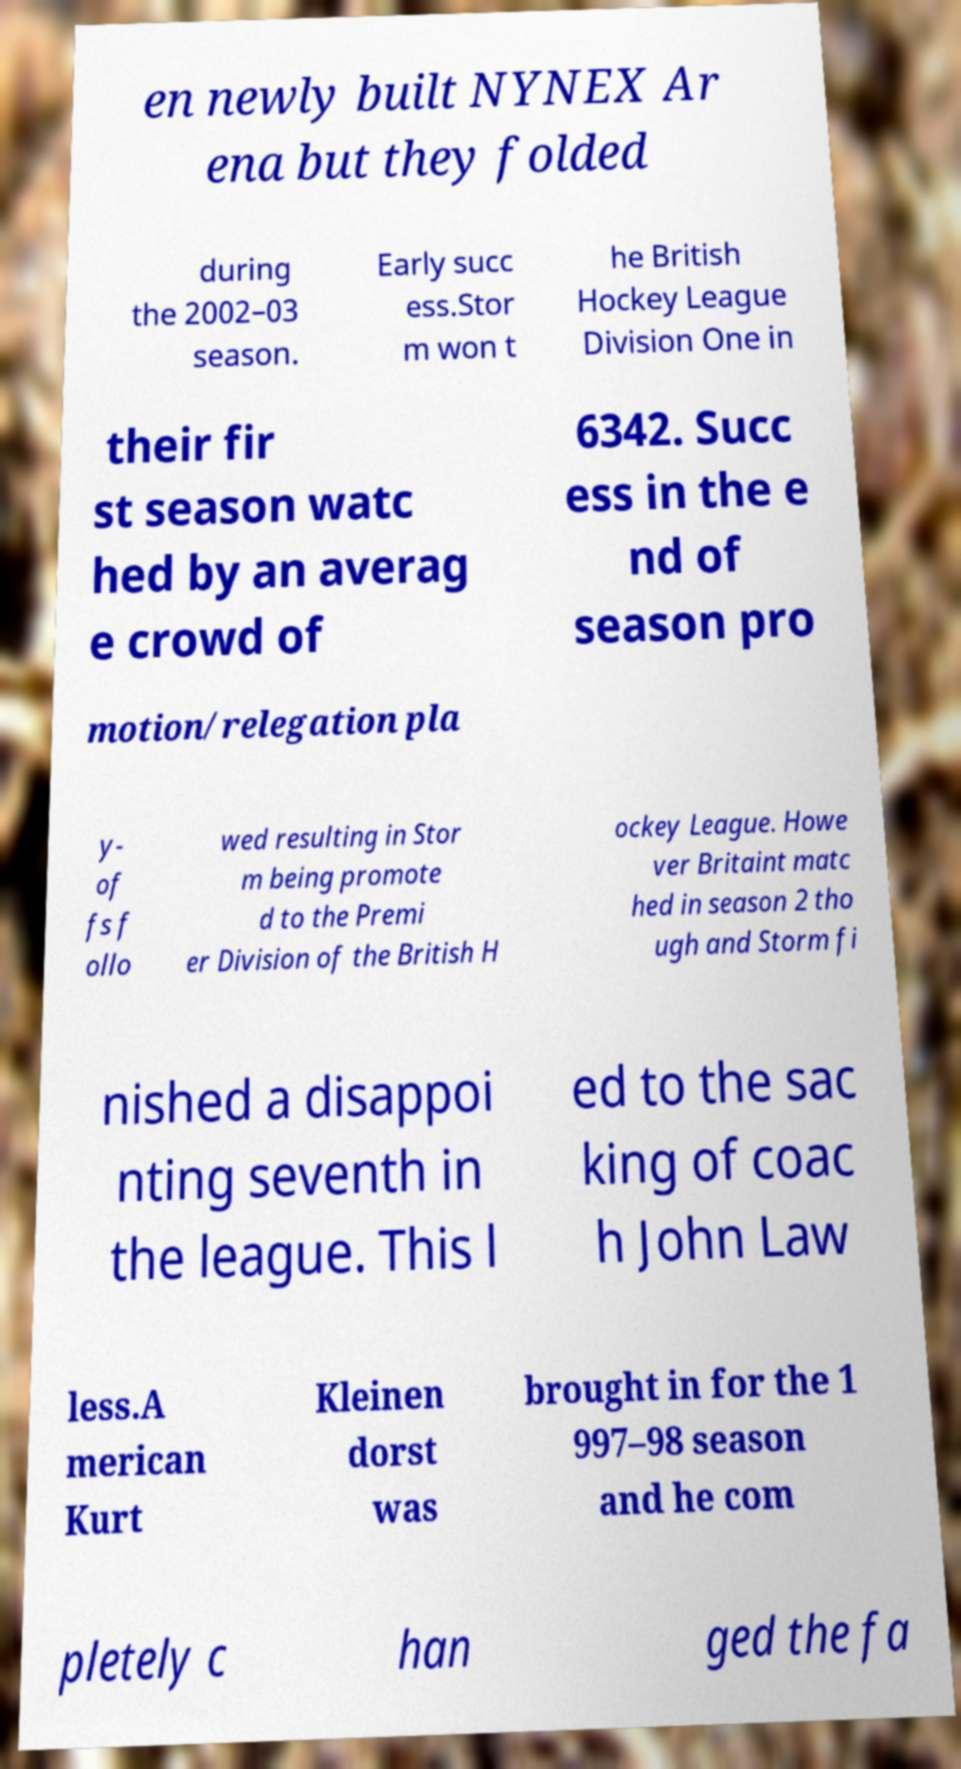There's text embedded in this image that I need extracted. Can you transcribe it verbatim? en newly built NYNEX Ar ena but they folded during the 2002–03 season. Early succ ess.Stor m won t he British Hockey League Division One in their fir st season watc hed by an averag e crowd of 6342. Succ ess in the e nd of season pro motion/relegation pla y- of fs f ollo wed resulting in Stor m being promote d to the Premi er Division of the British H ockey League. Howe ver Britaint matc hed in season 2 tho ugh and Storm fi nished a disappoi nting seventh in the league. This l ed to the sac king of coac h John Law less.A merican Kurt Kleinen dorst was brought in for the 1 997–98 season and he com pletely c han ged the fa 